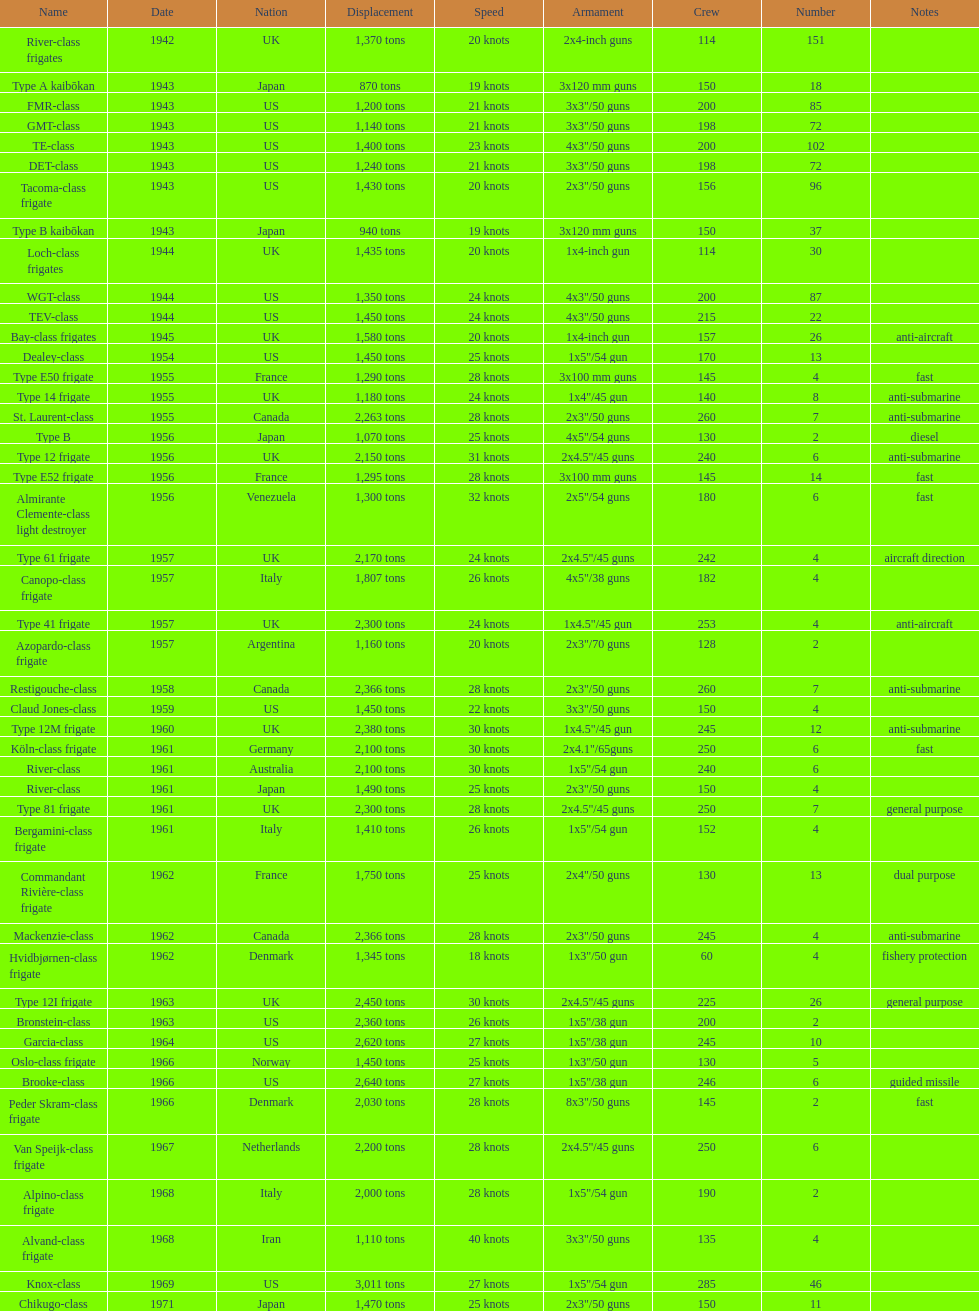What is the peak speed? 40 knots. 